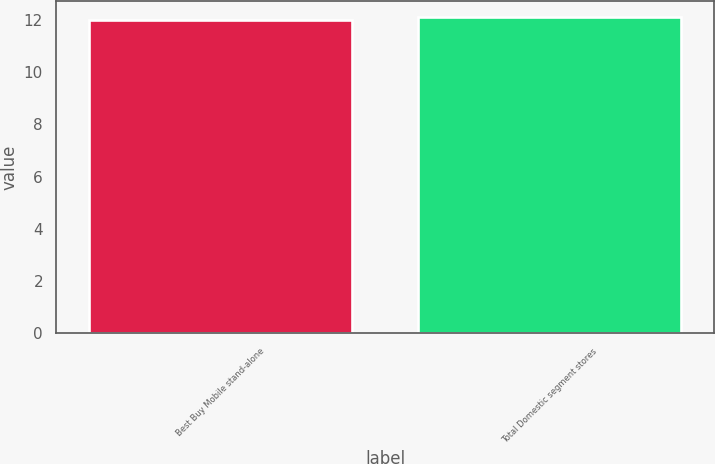<chart> <loc_0><loc_0><loc_500><loc_500><bar_chart><fcel>Best Buy Mobile stand-alone<fcel>Total Domestic segment stores<nl><fcel>12<fcel>12.1<nl></chart> 